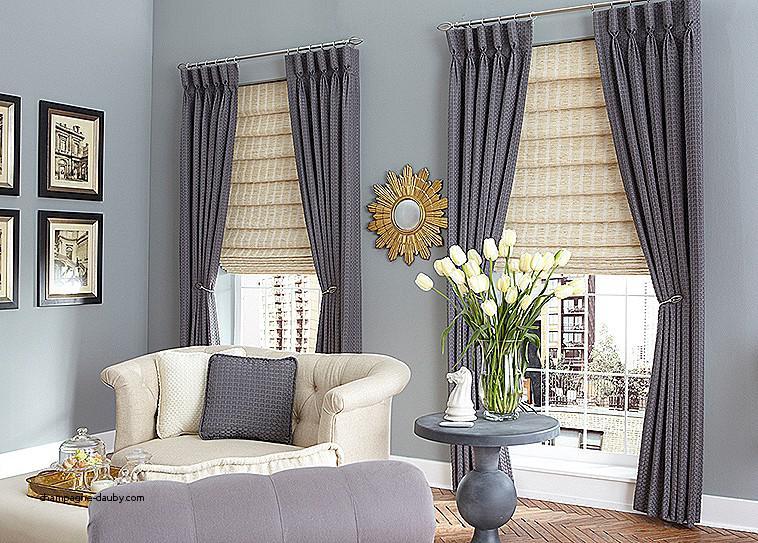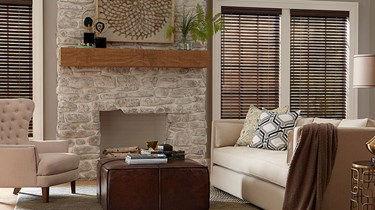The first image is the image on the left, the second image is the image on the right. Analyze the images presented: Is the assertion "Each image shows three blinds covering three windows side-by-side on the same wall." valid? Answer yes or no. No. The first image is the image on the left, the second image is the image on the right. Examine the images to the left and right. Is the description "A room features a table on a rug in front of a couch, which is in front of windows with three colored shades." accurate? Answer yes or no. No. 